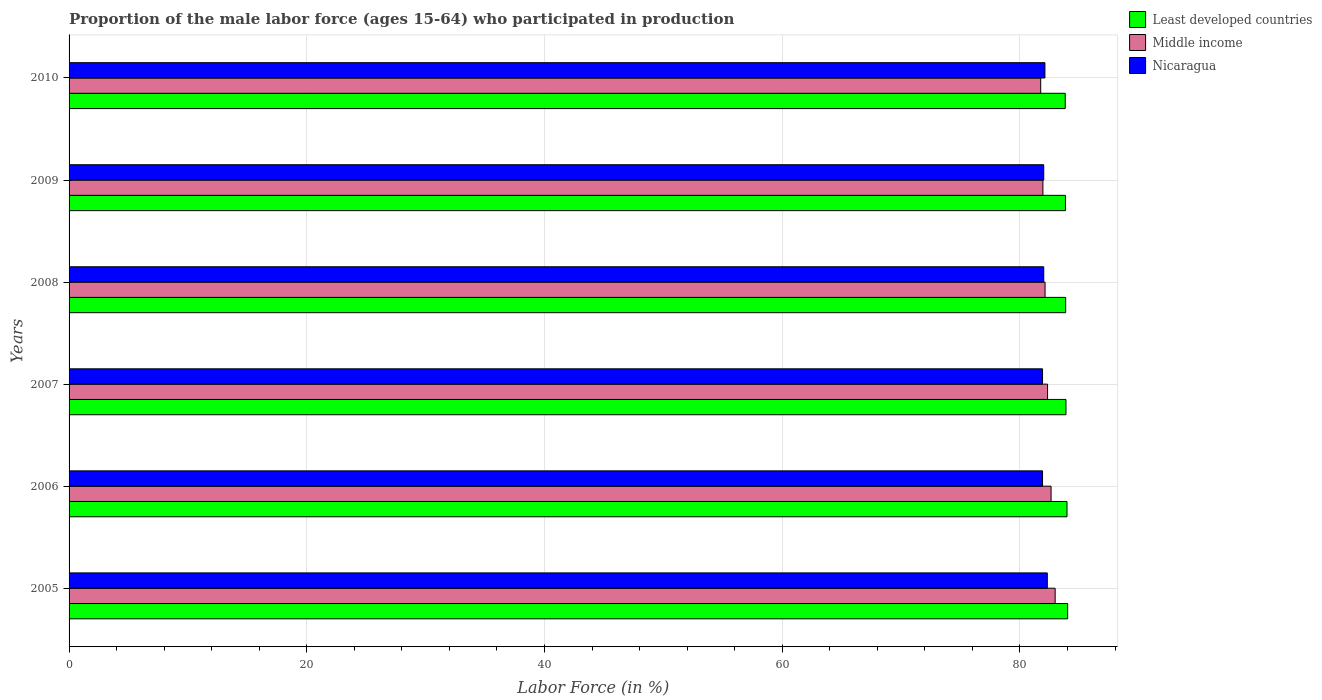How many different coloured bars are there?
Your response must be concise. 3. How many groups of bars are there?
Keep it short and to the point. 6. Are the number of bars per tick equal to the number of legend labels?
Give a very brief answer. Yes. How many bars are there on the 4th tick from the bottom?
Your answer should be very brief. 3. What is the label of the 5th group of bars from the top?
Keep it short and to the point. 2006. In how many cases, is the number of bars for a given year not equal to the number of legend labels?
Offer a terse response. 0. What is the proportion of the male labor force who participated in production in Least developed countries in 2008?
Make the answer very short. 83.85. Across all years, what is the maximum proportion of the male labor force who participated in production in Middle income?
Keep it short and to the point. 82.96. Across all years, what is the minimum proportion of the male labor force who participated in production in Nicaragua?
Keep it short and to the point. 81.9. In which year was the proportion of the male labor force who participated in production in Least developed countries minimum?
Give a very brief answer. 2010. What is the total proportion of the male labor force who participated in production in Middle income in the graph?
Your response must be concise. 493.69. What is the difference between the proportion of the male labor force who participated in production in Middle income in 2005 and that in 2007?
Your answer should be compact. 0.64. What is the difference between the proportion of the male labor force who participated in production in Middle income in 2009 and the proportion of the male labor force who participated in production in Least developed countries in 2008?
Offer a terse response. -1.92. What is the average proportion of the male labor force who participated in production in Middle income per year?
Give a very brief answer. 82.28. In the year 2007, what is the difference between the proportion of the male labor force who participated in production in Nicaragua and proportion of the male labor force who participated in production in Least developed countries?
Offer a very short reply. -1.97. In how many years, is the proportion of the male labor force who participated in production in Least developed countries greater than 56 %?
Ensure brevity in your answer.  6. What is the ratio of the proportion of the male labor force who participated in production in Middle income in 2007 to that in 2008?
Offer a very short reply. 1. What is the difference between the highest and the second highest proportion of the male labor force who participated in production in Least developed countries?
Give a very brief answer. 0.06. What is the difference between the highest and the lowest proportion of the male labor force who participated in production in Nicaragua?
Provide a short and direct response. 0.4. In how many years, is the proportion of the male labor force who participated in production in Least developed countries greater than the average proportion of the male labor force who participated in production in Least developed countries taken over all years?
Ensure brevity in your answer.  2. What does the 2nd bar from the top in 2010 represents?
Your response must be concise. Middle income. What does the 1st bar from the bottom in 2010 represents?
Make the answer very short. Least developed countries. Are all the bars in the graph horizontal?
Make the answer very short. Yes. Does the graph contain any zero values?
Keep it short and to the point. No. What is the title of the graph?
Your response must be concise. Proportion of the male labor force (ages 15-64) who participated in production. What is the label or title of the X-axis?
Provide a short and direct response. Labor Force (in %). What is the Labor Force (in %) of Least developed countries in 2005?
Make the answer very short. 84.01. What is the Labor Force (in %) of Middle income in 2005?
Give a very brief answer. 82.96. What is the Labor Force (in %) in Nicaragua in 2005?
Keep it short and to the point. 82.3. What is the Labor Force (in %) in Least developed countries in 2006?
Give a very brief answer. 83.96. What is the Labor Force (in %) in Middle income in 2006?
Provide a short and direct response. 82.62. What is the Labor Force (in %) in Nicaragua in 2006?
Offer a very short reply. 81.9. What is the Labor Force (in %) of Least developed countries in 2007?
Keep it short and to the point. 83.87. What is the Labor Force (in %) of Middle income in 2007?
Your answer should be compact. 82.32. What is the Labor Force (in %) in Nicaragua in 2007?
Your answer should be very brief. 81.9. What is the Labor Force (in %) in Least developed countries in 2008?
Give a very brief answer. 83.85. What is the Labor Force (in %) in Middle income in 2008?
Provide a short and direct response. 82.11. What is the Labor Force (in %) in Nicaragua in 2008?
Ensure brevity in your answer.  82. What is the Labor Force (in %) in Least developed countries in 2009?
Give a very brief answer. 83.83. What is the Labor Force (in %) of Middle income in 2009?
Provide a short and direct response. 81.93. What is the Labor Force (in %) of Least developed countries in 2010?
Give a very brief answer. 83.81. What is the Labor Force (in %) in Middle income in 2010?
Provide a succinct answer. 81.74. What is the Labor Force (in %) in Nicaragua in 2010?
Provide a short and direct response. 82.1. Across all years, what is the maximum Labor Force (in %) in Least developed countries?
Provide a succinct answer. 84.01. Across all years, what is the maximum Labor Force (in %) of Middle income?
Your answer should be very brief. 82.96. Across all years, what is the maximum Labor Force (in %) of Nicaragua?
Your answer should be compact. 82.3. Across all years, what is the minimum Labor Force (in %) in Least developed countries?
Offer a very short reply. 83.81. Across all years, what is the minimum Labor Force (in %) of Middle income?
Offer a very short reply. 81.74. Across all years, what is the minimum Labor Force (in %) of Nicaragua?
Your response must be concise. 81.9. What is the total Labor Force (in %) in Least developed countries in the graph?
Give a very brief answer. 503.32. What is the total Labor Force (in %) in Middle income in the graph?
Ensure brevity in your answer.  493.69. What is the total Labor Force (in %) in Nicaragua in the graph?
Keep it short and to the point. 492.2. What is the difference between the Labor Force (in %) of Least developed countries in 2005 and that in 2006?
Offer a terse response. 0.06. What is the difference between the Labor Force (in %) in Middle income in 2005 and that in 2006?
Ensure brevity in your answer.  0.34. What is the difference between the Labor Force (in %) in Nicaragua in 2005 and that in 2006?
Give a very brief answer. 0.4. What is the difference between the Labor Force (in %) of Least developed countries in 2005 and that in 2007?
Offer a terse response. 0.14. What is the difference between the Labor Force (in %) of Middle income in 2005 and that in 2007?
Offer a terse response. 0.64. What is the difference between the Labor Force (in %) in Least developed countries in 2005 and that in 2008?
Your response must be concise. 0.17. What is the difference between the Labor Force (in %) in Middle income in 2005 and that in 2008?
Offer a terse response. 0.85. What is the difference between the Labor Force (in %) of Least developed countries in 2005 and that in 2009?
Provide a succinct answer. 0.19. What is the difference between the Labor Force (in %) in Middle income in 2005 and that in 2009?
Provide a succinct answer. 1.03. What is the difference between the Labor Force (in %) in Least developed countries in 2005 and that in 2010?
Keep it short and to the point. 0.2. What is the difference between the Labor Force (in %) in Middle income in 2005 and that in 2010?
Your answer should be very brief. 1.22. What is the difference between the Labor Force (in %) in Least developed countries in 2006 and that in 2007?
Provide a succinct answer. 0.09. What is the difference between the Labor Force (in %) of Middle income in 2006 and that in 2007?
Keep it short and to the point. 0.3. What is the difference between the Labor Force (in %) of Least developed countries in 2006 and that in 2008?
Give a very brief answer. 0.11. What is the difference between the Labor Force (in %) of Middle income in 2006 and that in 2008?
Your response must be concise. 0.51. What is the difference between the Labor Force (in %) in Least developed countries in 2006 and that in 2009?
Offer a terse response. 0.13. What is the difference between the Labor Force (in %) of Middle income in 2006 and that in 2009?
Make the answer very short. 0.69. What is the difference between the Labor Force (in %) of Nicaragua in 2006 and that in 2009?
Make the answer very short. -0.1. What is the difference between the Labor Force (in %) of Least developed countries in 2006 and that in 2010?
Your answer should be very brief. 0.15. What is the difference between the Labor Force (in %) in Middle income in 2006 and that in 2010?
Your answer should be very brief. 0.87. What is the difference between the Labor Force (in %) of Nicaragua in 2006 and that in 2010?
Ensure brevity in your answer.  -0.2. What is the difference between the Labor Force (in %) of Least developed countries in 2007 and that in 2008?
Your response must be concise. 0.02. What is the difference between the Labor Force (in %) in Middle income in 2007 and that in 2008?
Offer a terse response. 0.21. What is the difference between the Labor Force (in %) of Least developed countries in 2007 and that in 2009?
Ensure brevity in your answer.  0.04. What is the difference between the Labor Force (in %) in Middle income in 2007 and that in 2009?
Ensure brevity in your answer.  0.39. What is the difference between the Labor Force (in %) of Least developed countries in 2007 and that in 2010?
Your response must be concise. 0.06. What is the difference between the Labor Force (in %) in Middle income in 2007 and that in 2010?
Offer a terse response. 0.58. What is the difference between the Labor Force (in %) in Nicaragua in 2007 and that in 2010?
Ensure brevity in your answer.  -0.2. What is the difference between the Labor Force (in %) of Least developed countries in 2008 and that in 2009?
Make the answer very short. 0.02. What is the difference between the Labor Force (in %) in Middle income in 2008 and that in 2009?
Provide a short and direct response. 0.18. What is the difference between the Labor Force (in %) of Nicaragua in 2008 and that in 2009?
Your response must be concise. 0. What is the difference between the Labor Force (in %) in Least developed countries in 2008 and that in 2010?
Make the answer very short. 0.04. What is the difference between the Labor Force (in %) in Middle income in 2008 and that in 2010?
Ensure brevity in your answer.  0.37. What is the difference between the Labor Force (in %) in Nicaragua in 2008 and that in 2010?
Offer a very short reply. -0.1. What is the difference between the Labor Force (in %) in Least developed countries in 2009 and that in 2010?
Ensure brevity in your answer.  0.02. What is the difference between the Labor Force (in %) in Middle income in 2009 and that in 2010?
Give a very brief answer. 0.19. What is the difference between the Labor Force (in %) of Nicaragua in 2009 and that in 2010?
Provide a short and direct response. -0.1. What is the difference between the Labor Force (in %) of Least developed countries in 2005 and the Labor Force (in %) of Middle income in 2006?
Keep it short and to the point. 1.39. What is the difference between the Labor Force (in %) in Least developed countries in 2005 and the Labor Force (in %) in Nicaragua in 2006?
Give a very brief answer. 2.11. What is the difference between the Labor Force (in %) in Middle income in 2005 and the Labor Force (in %) in Nicaragua in 2006?
Provide a succinct answer. 1.06. What is the difference between the Labor Force (in %) of Least developed countries in 2005 and the Labor Force (in %) of Middle income in 2007?
Your answer should be very brief. 1.69. What is the difference between the Labor Force (in %) in Least developed countries in 2005 and the Labor Force (in %) in Nicaragua in 2007?
Your answer should be compact. 2.11. What is the difference between the Labor Force (in %) in Middle income in 2005 and the Labor Force (in %) in Nicaragua in 2007?
Make the answer very short. 1.06. What is the difference between the Labor Force (in %) of Least developed countries in 2005 and the Labor Force (in %) of Middle income in 2008?
Keep it short and to the point. 1.9. What is the difference between the Labor Force (in %) of Least developed countries in 2005 and the Labor Force (in %) of Nicaragua in 2008?
Your answer should be very brief. 2.01. What is the difference between the Labor Force (in %) of Middle income in 2005 and the Labor Force (in %) of Nicaragua in 2008?
Your answer should be compact. 0.96. What is the difference between the Labor Force (in %) in Least developed countries in 2005 and the Labor Force (in %) in Middle income in 2009?
Offer a very short reply. 2.08. What is the difference between the Labor Force (in %) in Least developed countries in 2005 and the Labor Force (in %) in Nicaragua in 2009?
Offer a very short reply. 2.01. What is the difference between the Labor Force (in %) in Middle income in 2005 and the Labor Force (in %) in Nicaragua in 2009?
Provide a short and direct response. 0.96. What is the difference between the Labor Force (in %) in Least developed countries in 2005 and the Labor Force (in %) in Middle income in 2010?
Your answer should be compact. 2.27. What is the difference between the Labor Force (in %) in Least developed countries in 2005 and the Labor Force (in %) in Nicaragua in 2010?
Keep it short and to the point. 1.91. What is the difference between the Labor Force (in %) in Middle income in 2005 and the Labor Force (in %) in Nicaragua in 2010?
Your response must be concise. 0.86. What is the difference between the Labor Force (in %) of Least developed countries in 2006 and the Labor Force (in %) of Middle income in 2007?
Keep it short and to the point. 1.63. What is the difference between the Labor Force (in %) of Least developed countries in 2006 and the Labor Force (in %) of Nicaragua in 2007?
Your answer should be very brief. 2.06. What is the difference between the Labor Force (in %) of Middle income in 2006 and the Labor Force (in %) of Nicaragua in 2007?
Your answer should be compact. 0.72. What is the difference between the Labor Force (in %) in Least developed countries in 2006 and the Labor Force (in %) in Middle income in 2008?
Make the answer very short. 1.85. What is the difference between the Labor Force (in %) of Least developed countries in 2006 and the Labor Force (in %) of Nicaragua in 2008?
Offer a terse response. 1.96. What is the difference between the Labor Force (in %) of Middle income in 2006 and the Labor Force (in %) of Nicaragua in 2008?
Offer a terse response. 0.62. What is the difference between the Labor Force (in %) in Least developed countries in 2006 and the Labor Force (in %) in Middle income in 2009?
Your answer should be very brief. 2.03. What is the difference between the Labor Force (in %) in Least developed countries in 2006 and the Labor Force (in %) in Nicaragua in 2009?
Ensure brevity in your answer.  1.96. What is the difference between the Labor Force (in %) of Middle income in 2006 and the Labor Force (in %) of Nicaragua in 2009?
Offer a very short reply. 0.62. What is the difference between the Labor Force (in %) of Least developed countries in 2006 and the Labor Force (in %) of Middle income in 2010?
Your answer should be compact. 2.21. What is the difference between the Labor Force (in %) of Least developed countries in 2006 and the Labor Force (in %) of Nicaragua in 2010?
Provide a short and direct response. 1.86. What is the difference between the Labor Force (in %) in Middle income in 2006 and the Labor Force (in %) in Nicaragua in 2010?
Provide a short and direct response. 0.52. What is the difference between the Labor Force (in %) of Least developed countries in 2007 and the Labor Force (in %) of Middle income in 2008?
Offer a very short reply. 1.76. What is the difference between the Labor Force (in %) of Least developed countries in 2007 and the Labor Force (in %) of Nicaragua in 2008?
Give a very brief answer. 1.87. What is the difference between the Labor Force (in %) in Middle income in 2007 and the Labor Force (in %) in Nicaragua in 2008?
Your answer should be very brief. 0.32. What is the difference between the Labor Force (in %) of Least developed countries in 2007 and the Labor Force (in %) of Middle income in 2009?
Make the answer very short. 1.94. What is the difference between the Labor Force (in %) in Least developed countries in 2007 and the Labor Force (in %) in Nicaragua in 2009?
Keep it short and to the point. 1.87. What is the difference between the Labor Force (in %) of Middle income in 2007 and the Labor Force (in %) of Nicaragua in 2009?
Offer a very short reply. 0.32. What is the difference between the Labor Force (in %) of Least developed countries in 2007 and the Labor Force (in %) of Middle income in 2010?
Your answer should be very brief. 2.13. What is the difference between the Labor Force (in %) in Least developed countries in 2007 and the Labor Force (in %) in Nicaragua in 2010?
Offer a terse response. 1.77. What is the difference between the Labor Force (in %) in Middle income in 2007 and the Labor Force (in %) in Nicaragua in 2010?
Your answer should be very brief. 0.22. What is the difference between the Labor Force (in %) of Least developed countries in 2008 and the Labor Force (in %) of Middle income in 2009?
Your answer should be very brief. 1.92. What is the difference between the Labor Force (in %) in Least developed countries in 2008 and the Labor Force (in %) in Nicaragua in 2009?
Offer a very short reply. 1.85. What is the difference between the Labor Force (in %) of Least developed countries in 2008 and the Labor Force (in %) of Middle income in 2010?
Keep it short and to the point. 2.1. What is the difference between the Labor Force (in %) of Least developed countries in 2008 and the Labor Force (in %) of Nicaragua in 2010?
Your answer should be very brief. 1.75. What is the difference between the Labor Force (in %) in Middle income in 2008 and the Labor Force (in %) in Nicaragua in 2010?
Keep it short and to the point. 0.01. What is the difference between the Labor Force (in %) in Least developed countries in 2009 and the Labor Force (in %) in Middle income in 2010?
Offer a terse response. 2.08. What is the difference between the Labor Force (in %) in Least developed countries in 2009 and the Labor Force (in %) in Nicaragua in 2010?
Keep it short and to the point. 1.73. What is the difference between the Labor Force (in %) of Middle income in 2009 and the Labor Force (in %) of Nicaragua in 2010?
Make the answer very short. -0.17. What is the average Labor Force (in %) in Least developed countries per year?
Provide a succinct answer. 83.89. What is the average Labor Force (in %) of Middle income per year?
Keep it short and to the point. 82.28. What is the average Labor Force (in %) of Nicaragua per year?
Offer a terse response. 82.03. In the year 2005, what is the difference between the Labor Force (in %) of Least developed countries and Labor Force (in %) of Middle income?
Give a very brief answer. 1.05. In the year 2005, what is the difference between the Labor Force (in %) in Least developed countries and Labor Force (in %) in Nicaragua?
Give a very brief answer. 1.71. In the year 2005, what is the difference between the Labor Force (in %) in Middle income and Labor Force (in %) in Nicaragua?
Make the answer very short. 0.66. In the year 2006, what is the difference between the Labor Force (in %) in Least developed countries and Labor Force (in %) in Middle income?
Your response must be concise. 1.34. In the year 2006, what is the difference between the Labor Force (in %) of Least developed countries and Labor Force (in %) of Nicaragua?
Provide a short and direct response. 2.06. In the year 2006, what is the difference between the Labor Force (in %) of Middle income and Labor Force (in %) of Nicaragua?
Provide a succinct answer. 0.72. In the year 2007, what is the difference between the Labor Force (in %) in Least developed countries and Labor Force (in %) in Middle income?
Your response must be concise. 1.55. In the year 2007, what is the difference between the Labor Force (in %) of Least developed countries and Labor Force (in %) of Nicaragua?
Provide a short and direct response. 1.97. In the year 2007, what is the difference between the Labor Force (in %) in Middle income and Labor Force (in %) in Nicaragua?
Offer a very short reply. 0.42. In the year 2008, what is the difference between the Labor Force (in %) of Least developed countries and Labor Force (in %) of Middle income?
Give a very brief answer. 1.73. In the year 2008, what is the difference between the Labor Force (in %) in Least developed countries and Labor Force (in %) in Nicaragua?
Offer a very short reply. 1.85. In the year 2008, what is the difference between the Labor Force (in %) in Middle income and Labor Force (in %) in Nicaragua?
Your answer should be compact. 0.11. In the year 2009, what is the difference between the Labor Force (in %) in Least developed countries and Labor Force (in %) in Middle income?
Keep it short and to the point. 1.9. In the year 2009, what is the difference between the Labor Force (in %) in Least developed countries and Labor Force (in %) in Nicaragua?
Your answer should be very brief. 1.83. In the year 2009, what is the difference between the Labor Force (in %) of Middle income and Labor Force (in %) of Nicaragua?
Keep it short and to the point. -0.07. In the year 2010, what is the difference between the Labor Force (in %) of Least developed countries and Labor Force (in %) of Middle income?
Make the answer very short. 2.07. In the year 2010, what is the difference between the Labor Force (in %) in Least developed countries and Labor Force (in %) in Nicaragua?
Your response must be concise. 1.71. In the year 2010, what is the difference between the Labor Force (in %) in Middle income and Labor Force (in %) in Nicaragua?
Provide a succinct answer. -0.36. What is the ratio of the Labor Force (in %) in Least developed countries in 2005 to that in 2006?
Offer a very short reply. 1. What is the ratio of the Labor Force (in %) of Middle income in 2005 to that in 2006?
Offer a terse response. 1. What is the ratio of the Labor Force (in %) of Nicaragua in 2005 to that in 2006?
Give a very brief answer. 1. What is the ratio of the Labor Force (in %) in Least developed countries in 2005 to that in 2007?
Provide a short and direct response. 1. What is the ratio of the Labor Force (in %) of Middle income in 2005 to that in 2007?
Give a very brief answer. 1.01. What is the ratio of the Labor Force (in %) of Nicaragua in 2005 to that in 2007?
Your response must be concise. 1. What is the ratio of the Labor Force (in %) of Least developed countries in 2005 to that in 2008?
Your answer should be compact. 1. What is the ratio of the Labor Force (in %) in Middle income in 2005 to that in 2008?
Give a very brief answer. 1.01. What is the ratio of the Labor Force (in %) in Nicaragua in 2005 to that in 2008?
Make the answer very short. 1. What is the ratio of the Labor Force (in %) in Least developed countries in 2005 to that in 2009?
Give a very brief answer. 1. What is the ratio of the Labor Force (in %) in Middle income in 2005 to that in 2009?
Provide a succinct answer. 1.01. What is the ratio of the Labor Force (in %) in Middle income in 2005 to that in 2010?
Give a very brief answer. 1.01. What is the ratio of the Labor Force (in %) of Middle income in 2006 to that in 2007?
Provide a short and direct response. 1. What is the ratio of the Labor Force (in %) in Nicaragua in 2006 to that in 2007?
Make the answer very short. 1. What is the ratio of the Labor Force (in %) of Middle income in 2006 to that in 2008?
Give a very brief answer. 1.01. What is the ratio of the Labor Force (in %) in Nicaragua in 2006 to that in 2008?
Provide a succinct answer. 1. What is the ratio of the Labor Force (in %) in Least developed countries in 2006 to that in 2009?
Offer a terse response. 1. What is the ratio of the Labor Force (in %) in Middle income in 2006 to that in 2009?
Keep it short and to the point. 1.01. What is the ratio of the Labor Force (in %) of Nicaragua in 2006 to that in 2009?
Your answer should be very brief. 1. What is the ratio of the Labor Force (in %) in Middle income in 2006 to that in 2010?
Offer a very short reply. 1.01. What is the ratio of the Labor Force (in %) of Nicaragua in 2006 to that in 2010?
Provide a short and direct response. 1. What is the ratio of the Labor Force (in %) of Least developed countries in 2007 to that in 2008?
Provide a succinct answer. 1. What is the ratio of the Labor Force (in %) in Least developed countries in 2007 to that in 2009?
Your response must be concise. 1. What is the ratio of the Labor Force (in %) in Middle income in 2007 to that in 2009?
Your response must be concise. 1. What is the ratio of the Labor Force (in %) in Least developed countries in 2007 to that in 2010?
Offer a terse response. 1. What is the ratio of the Labor Force (in %) of Middle income in 2007 to that in 2010?
Ensure brevity in your answer.  1.01. What is the ratio of the Labor Force (in %) in Least developed countries in 2008 to that in 2009?
Your response must be concise. 1. What is the ratio of the Labor Force (in %) of Least developed countries in 2008 to that in 2010?
Offer a terse response. 1. What is the ratio of the Labor Force (in %) in Middle income in 2008 to that in 2010?
Your answer should be very brief. 1. What is the ratio of the Labor Force (in %) of Middle income in 2009 to that in 2010?
Give a very brief answer. 1. What is the difference between the highest and the second highest Labor Force (in %) of Least developed countries?
Provide a succinct answer. 0.06. What is the difference between the highest and the second highest Labor Force (in %) of Middle income?
Keep it short and to the point. 0.34. What is the difference between the highest and the second highest Labor Force (in %) of Nicaragua?
Your answer should be compact. 0.2. What is the difference between the highest and the lowest Labor Force (in %) of Least developed countries?
Ensure brevity in your answer.  0.2. What is the difference between the highest and the lowest Labor Force (in %) in Middle income?
Offer a very short reply. 1.22. 